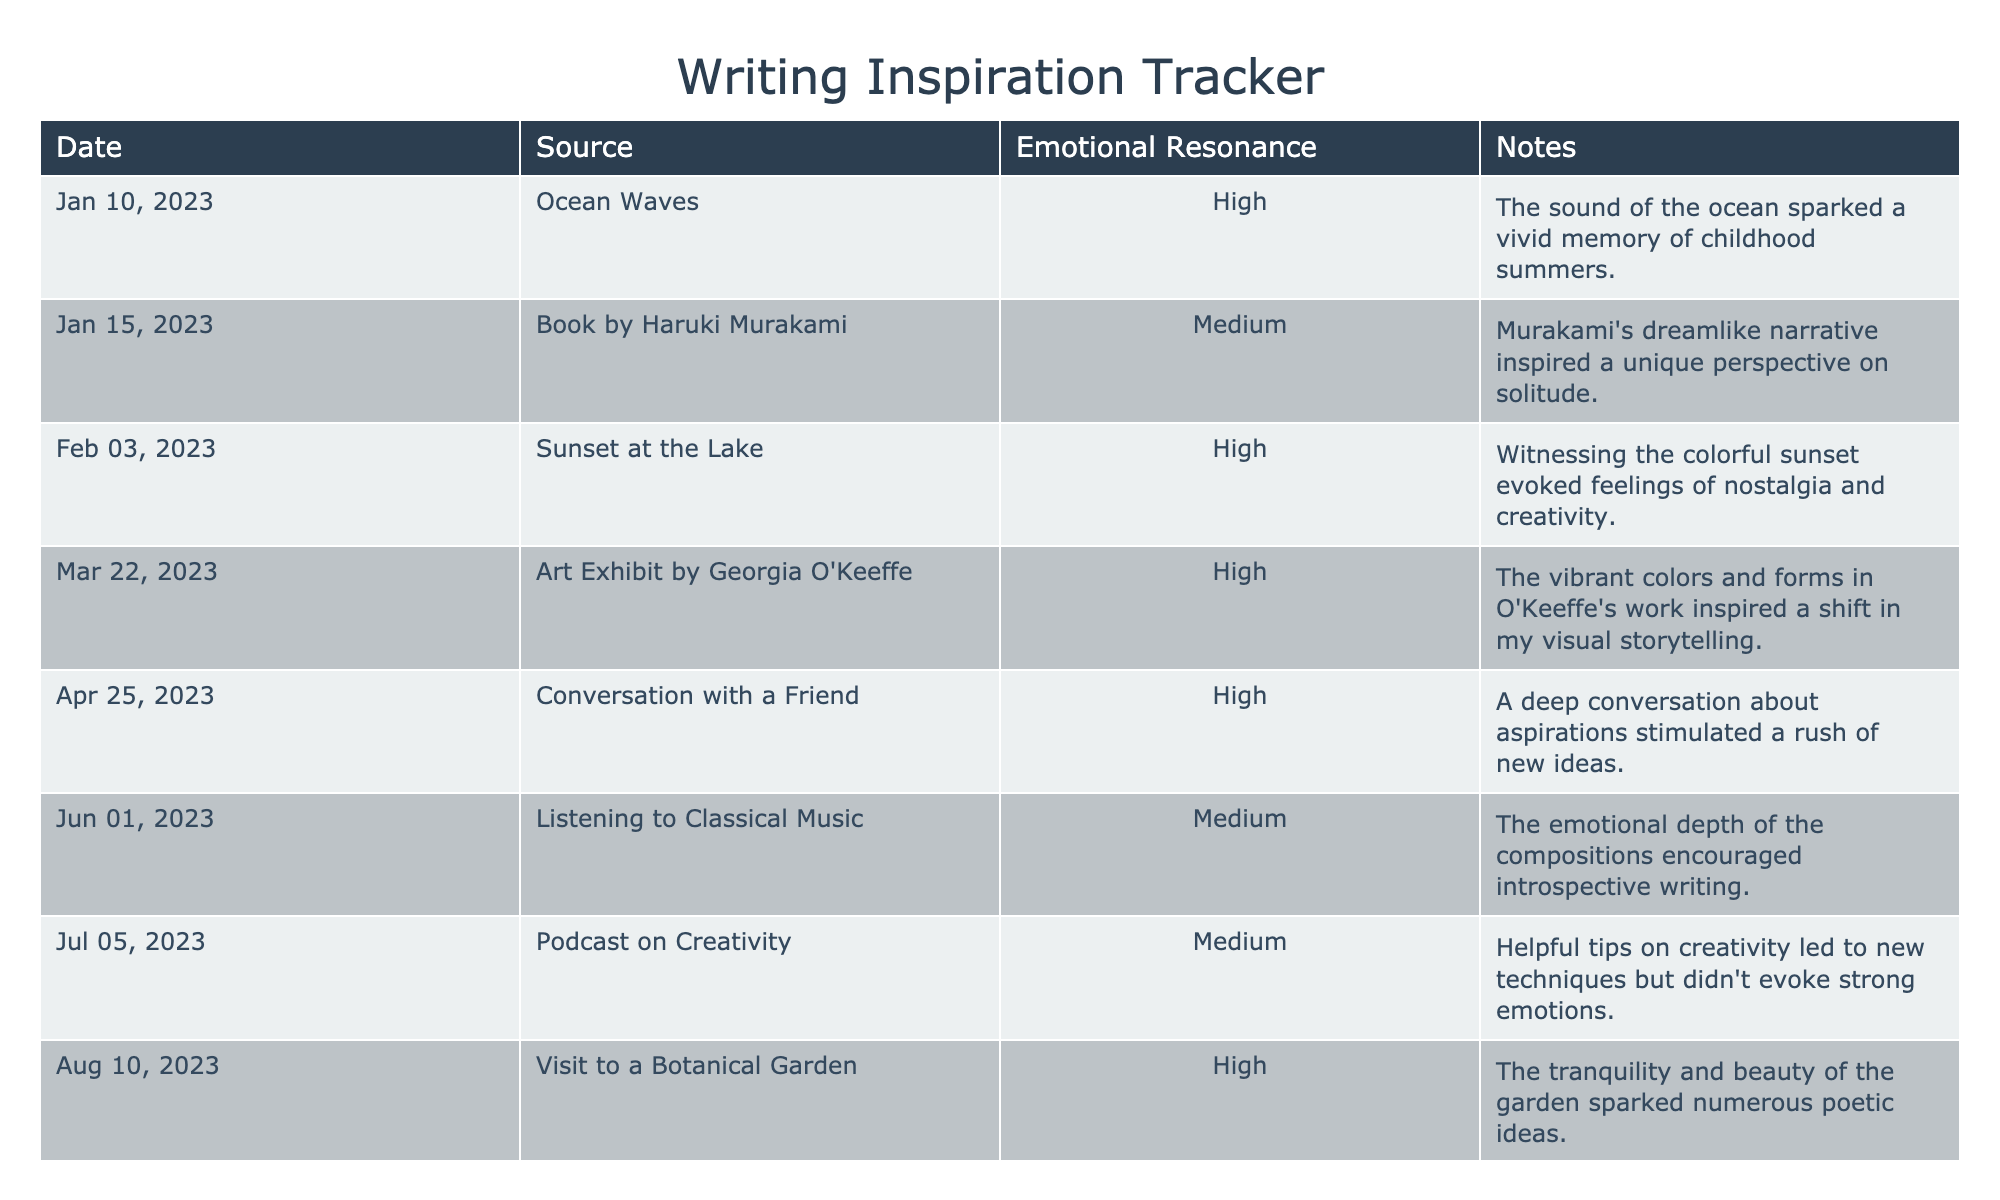What source of inspiration had the highest emotional resonance? The table shows multiple entries, and the 'Emotional Resonance' column indicates 'High' for several sources. The first source listed that has high resonance is "Ocean Waves."
Answer: Ocean Waves How many sources inspired high emotional resonance? By counting the 'High' entries in the 'Emotional Resonance' column, there are six sources that fit this criteria: Ocean Waves, Sunset at the Lake, Art Exhibit by Georgia O'Keeffe, Conversation with a Friend, Visit to a Botanical Garden, and Moonlight Night.
Answer: 6 What is the emotional resonance of the podcast on creativity? Referring to the 'Emotional Resonance' column, the entry for "Podcast on Creativity" shows a resonance of 'Medium.'
Answer: Medium Which inspired sources on the table related to nature? Looking at the 'Source' column, "Ocean Waves," "Sunset at the Lake," "Visit to a Botanical Garden," and "Moonlight Night" all relate to nature.
Answer: Ocean Waves, Sunset at the Lake, Visit to a Botanical Garden, Moonlight Night Did any source inspire writing on the same day as another entry? Reviewing the 'Date' column, all entries have unique dates, so there are no sources that share the same date.
Answer: No What was the date of the highest emotional resonance entry related to a friend? Reviewing for high emotional resonance linked to friendship leads us to "Conversation with a Friend," which has a date of April 25, 2023.
Answer: April 25, 2023 How many sources did not evoke strong emotions? Referring to the 'Emotional Resonance' column, only "Podcast on Creativity" and "Listening to Classical Music" have a 'Medium' emotional resonance, indicating lack of strong emotional evocation.
Answer: 2 What is the emotional resonance of the source that inspired a shift in visual storytelling? The 'Notes' for "Art Exhibit by Georgia O'Keeffe" mention inspiration for visual storytelling and it reports a 'High' emotional resonance in the table.
Answer: High How does the emotional resonance of "Book by Haruki Murakami" compare to "Listening to Classical Music"? "Book by Haruki Murakami" is listed as 'Medium', while "Listening to Classical Music" also has an emotional resonance of 'Medium', thus they are equivalent.
Answer: Equivalent What inspired writing on January 15, 2023? The entry on January 15, 2023, shows "Book by Haruki Murakami" as the source of inspiration.
Answer: Book by Haruki Murakami 